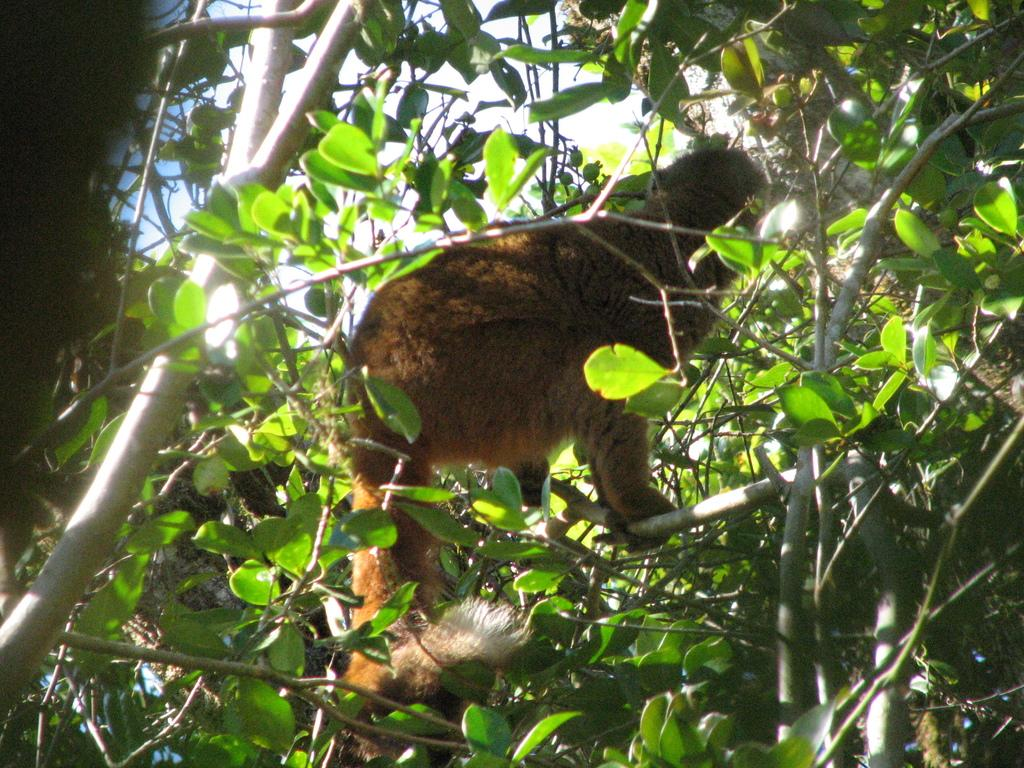What is on the tree in the image? There is an animal on the tree in the image. What can be seen at the top of the image? The sky is visible at the top of the image. What type of silk is draped over the bed in the image? There is no bed or silk present in the image; it only features an animal on a tree and the sky. How many glasses of water are visible on the tree in the image? There are no glasses of water present in the image; it only features an animal on a tree and the sky. 